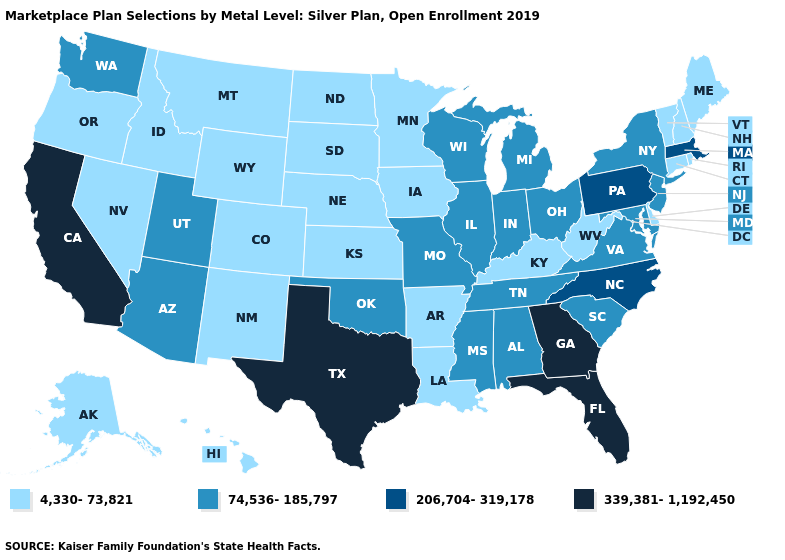What is the value of New York?
Short answer required. 74,536-185,797. Does California have the same value as Texas?
Give a very brief answer. Yes. What is the value of Iowa?
Short answer required. 4,330-73,821. Among the states that border New Mexico , does Utah have the highest value?
Answer briefly. No. What is the value of Delaware?
Answer briefly. 4,330-73,821. What is the highest value in the USA?
Give a very brief answer. 339,381-1,192,450. What is the highest value in the USA?
Write a very short answer. 339,381-1,192,450. Does Idaho have the same value as New Mexico?
Write a very short answer. Yes. What is the value of Maine?
Quick response, please. 4,330-73,821. Name the states that have a value in the range 206,704-319,178?
Keep it brief. Massachusetts, North Carolina, Pennsylvania. What is the value of Rhode Island?
Give a very brief answer. 4,330-73,821. Name the states that have a value in the range 74,536-185,797?
Give a very brief answer. Alabama, Arizona, Illinois, Indiana, Maryland, Michigan, Mississippi, Missouri, New Jersey, New York, Ohio, Oklahoma, South Carolina, Tennessee, Utah, Virginia, Washington, Wisconsin. What is the value of North Carolina?
Answer briefly. 206,704-319,178. What is the lowest value in the West?
Short answer required. 4,330-73,821. Does Arkansas have the same value as Minnesota?
Quick response, please. Yes. 